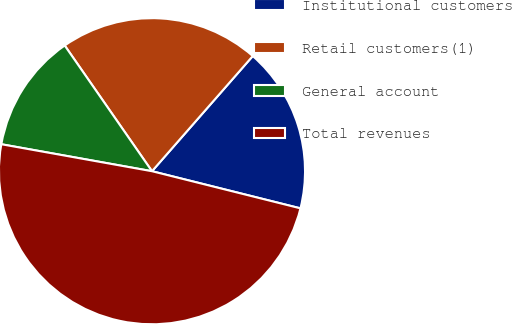Convert chart. <chart><loc_0><loc_0><loc_500><loc_500><pie_chart><fcel>Institutional customers<fcel>Retail customers(1)<fcel>General account<fcel>Total revenues<nl><fcel>17.46%<fcel>21.1%<fcel>12.52%<fcel>48.92%<nl></chart> 